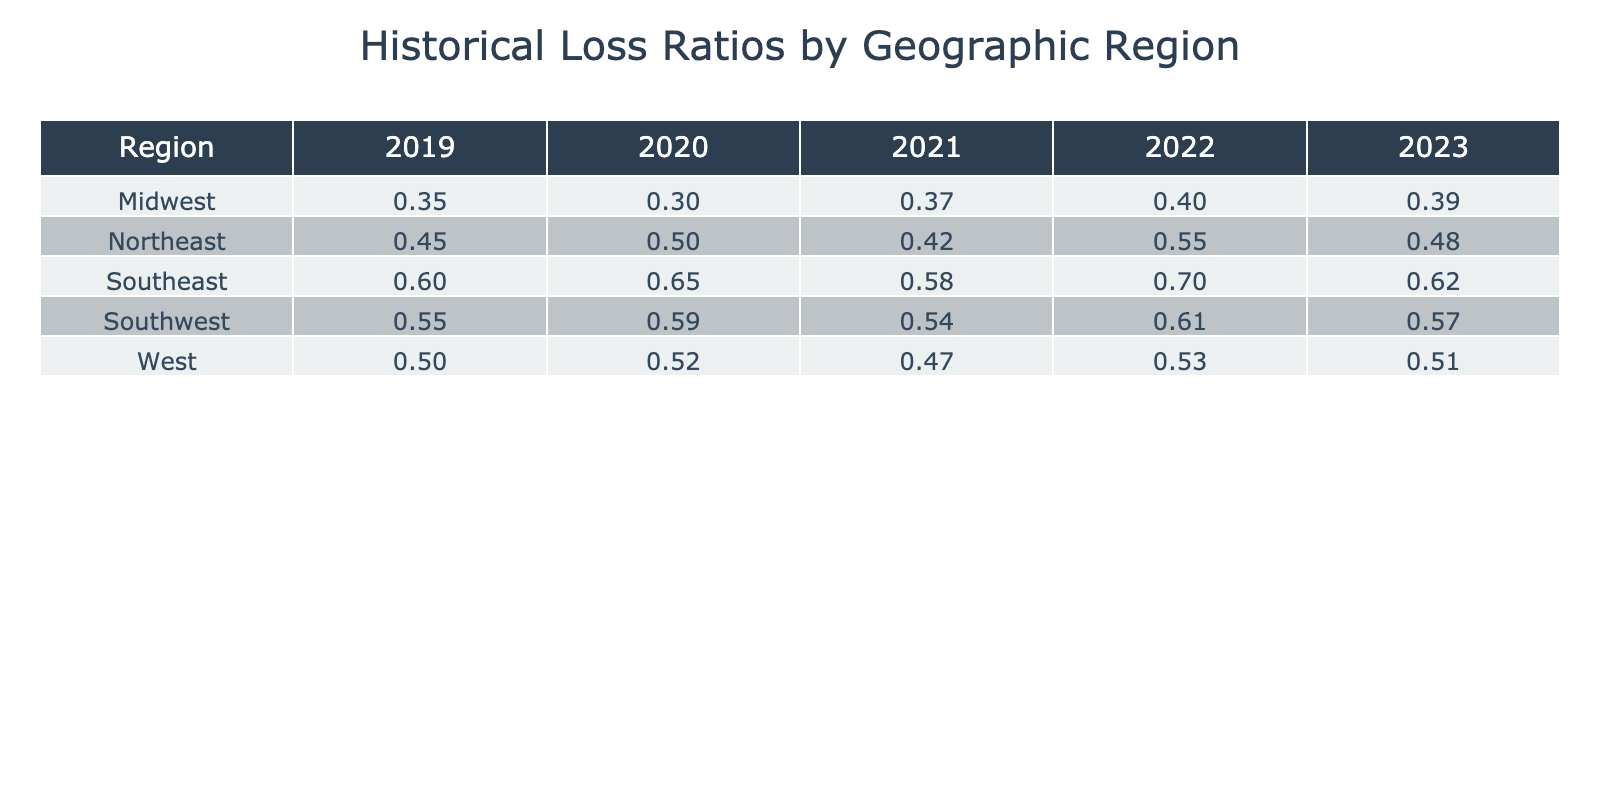What was the loss ratio in the Midwest for the year 2022? The table shows that the loss ratio for the Midwest region in 2022 is listed directly. By looking at the corresponding row for the Midwest and the column for the year 2022, we find the value of 0.40.
Answer: 0.40 Which region had the highest loss ratio in 2020? To determine the highest loss ratio in 2020, we compare the loss ratios for all regions for that year. The values are: Northeast 0.50, Southeast 0.65, Midwest 0.30, Southwest 0.59, and West 0.52. The Southeast has the highest value of 0.65.
Answer: Southeast What is the average loss ratio for the Southwest region over the past five years? We calculate the average by summing the loss ratios for the Southwest over the years 2019 to 2023 which are: 0.55 + 0.59 + 0.54 + 0.61 + 0.57 = 2.86. We then divide this sum by the number of years (5): 2.86 / 5 = 0.572.
Answer: 0.572 Is the loss ratio in the Northeast region decreasing over the past five years? To assess if the loss ratio is decreasing, we compare the values from 2019 (0.45), 2020 (0.50), 2021 (0.42), 2022 (0.55), and 2023 (0.48). The ratios fluctuate but do not show a consistent downward trend as the values go up and down.
Answer: No What is the difference in loss ratios between the Southeast and Midwest regions for the year 2023? For 2023, the loss ratio for the Southeast is 0.62 and for the Midwest, it is 0.39. To find the difference, we subtract the Midwest's loss ratio from the Southeast's: 0.62 - 0.39 = 0.23.
Answer: 0.23 In which year did the Northest region experience its lowest loss ratio? Looking at the Northeast region's loss ratios for each year: 2019 (0.45), 2020 (0.50), 2021 (0.42), 2022 (0.55), and 2023 (0.48), the lowest value is in 2021 with 0.42.
Answer: 2021 What is the highest average loss ratio across all regions for any single year? We calculate the average for each region for each year and identify the highest one. After analyzing each year, we find the annual loss ratios: 2019 (Northeast: 0.45, Southeast: 0.60, Midwest: 0.35, Southwest: 0.55, West: 0.50) gives an average of 0.49; 2020 gives an average of 0.51; and 2021 gives 0.45; 2022 gives 0.351; and 2023 gives 0.08. The highest is definitely 2020 at 0.51.
Answer: 0.51 